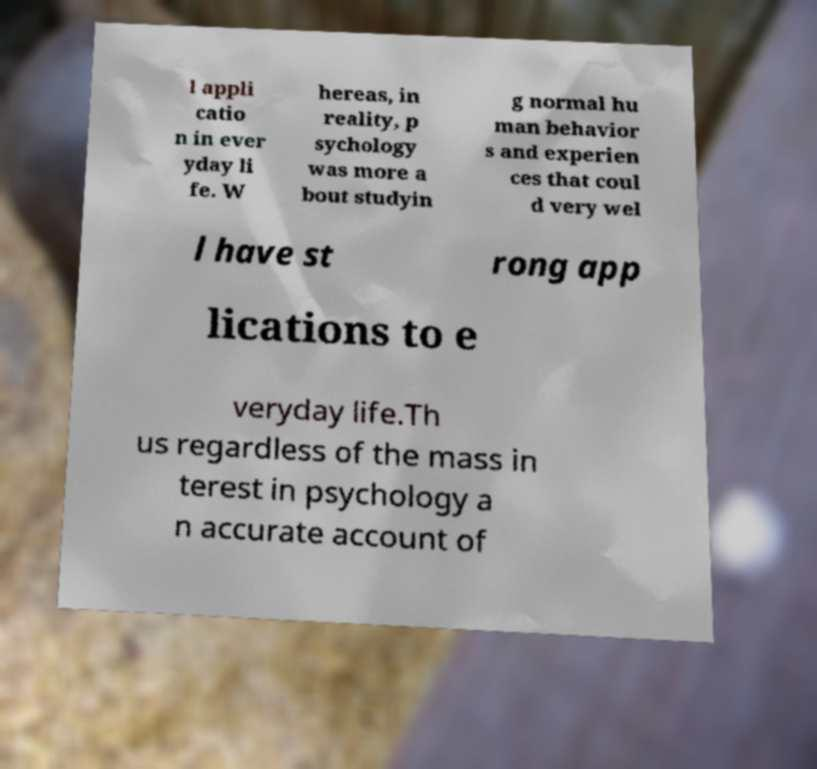Can you read and provide the text displayed in the image?This photo seems to have some interesting text. Can you extract and type it out for me? l appli catio n in ever yday li fe. W hereas, in reality, p sychology was more a bout studyin g normal hu man behavior s and experien ces that coul d very wel l have st rong app lications to e veryday life.Th us regardless of the mass in terest in psychology a n accurate account of 